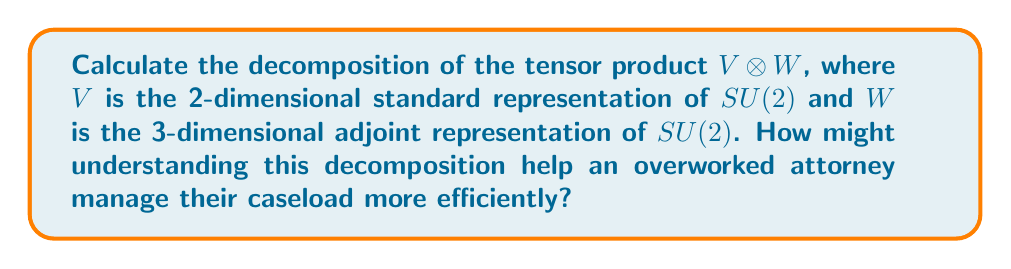Provide a solution to this math problem. 1) First, recall that for $SU(2)$, representations are labeled by their dimension, which is always odd for irreducible representations. The standard representation $V$ is the 2-dimensional representation, while the adjoint representation $W$ is the 3-dimensional representation.

2) To decompose $V \otimes W$, we can use the Clebsch-Gordan formula:

   $$(j_1) \otimes (j_2) = (|j_1 - j_2|) \oplus (|j_1 - j_2| + 1) \oplus ... \oplus (j_1 + j_2)$$

   where $(j)$ denotes the $(2j+1)$-dimensional irreducible representation of $SU(2)$.

3) In our case, $V$ corresponds to $(\frac{1}{2})$ and $W$ corresponds to $(1)$. So we have:

   $$(\frac{1}{2}) \otimes (1)$$

4) Applying the Clebsch-Gordan formula:

   $$|j_1 - j_2| = |\frac{1}{2} - 1| = \frac{1}{2}$$
   $$j_1 + j_2 = \frac{1}{2} + 1 = \frac{3}{2}$$

5) Therefore, the decomposition is:

   $$(\frac{1}{2}) \otimes (1) = (\frac{1}{2}) \oplus (\frac{3}{2})$$

6) In terms of dimensions, this means:

   $$2 \otimes 3 = 2 \oplus 4$$

This decomposition can be analogous to breaking down a complex legal case into simpler, manageable components. Just as the tensor product decomposes into a sum of simpler representations, a large caseload can be broken down into smaller, more focused tasks.
Answer: $V \otimes W = (\frac{1}{2}) \oplus (\frac{3}{2})$ 